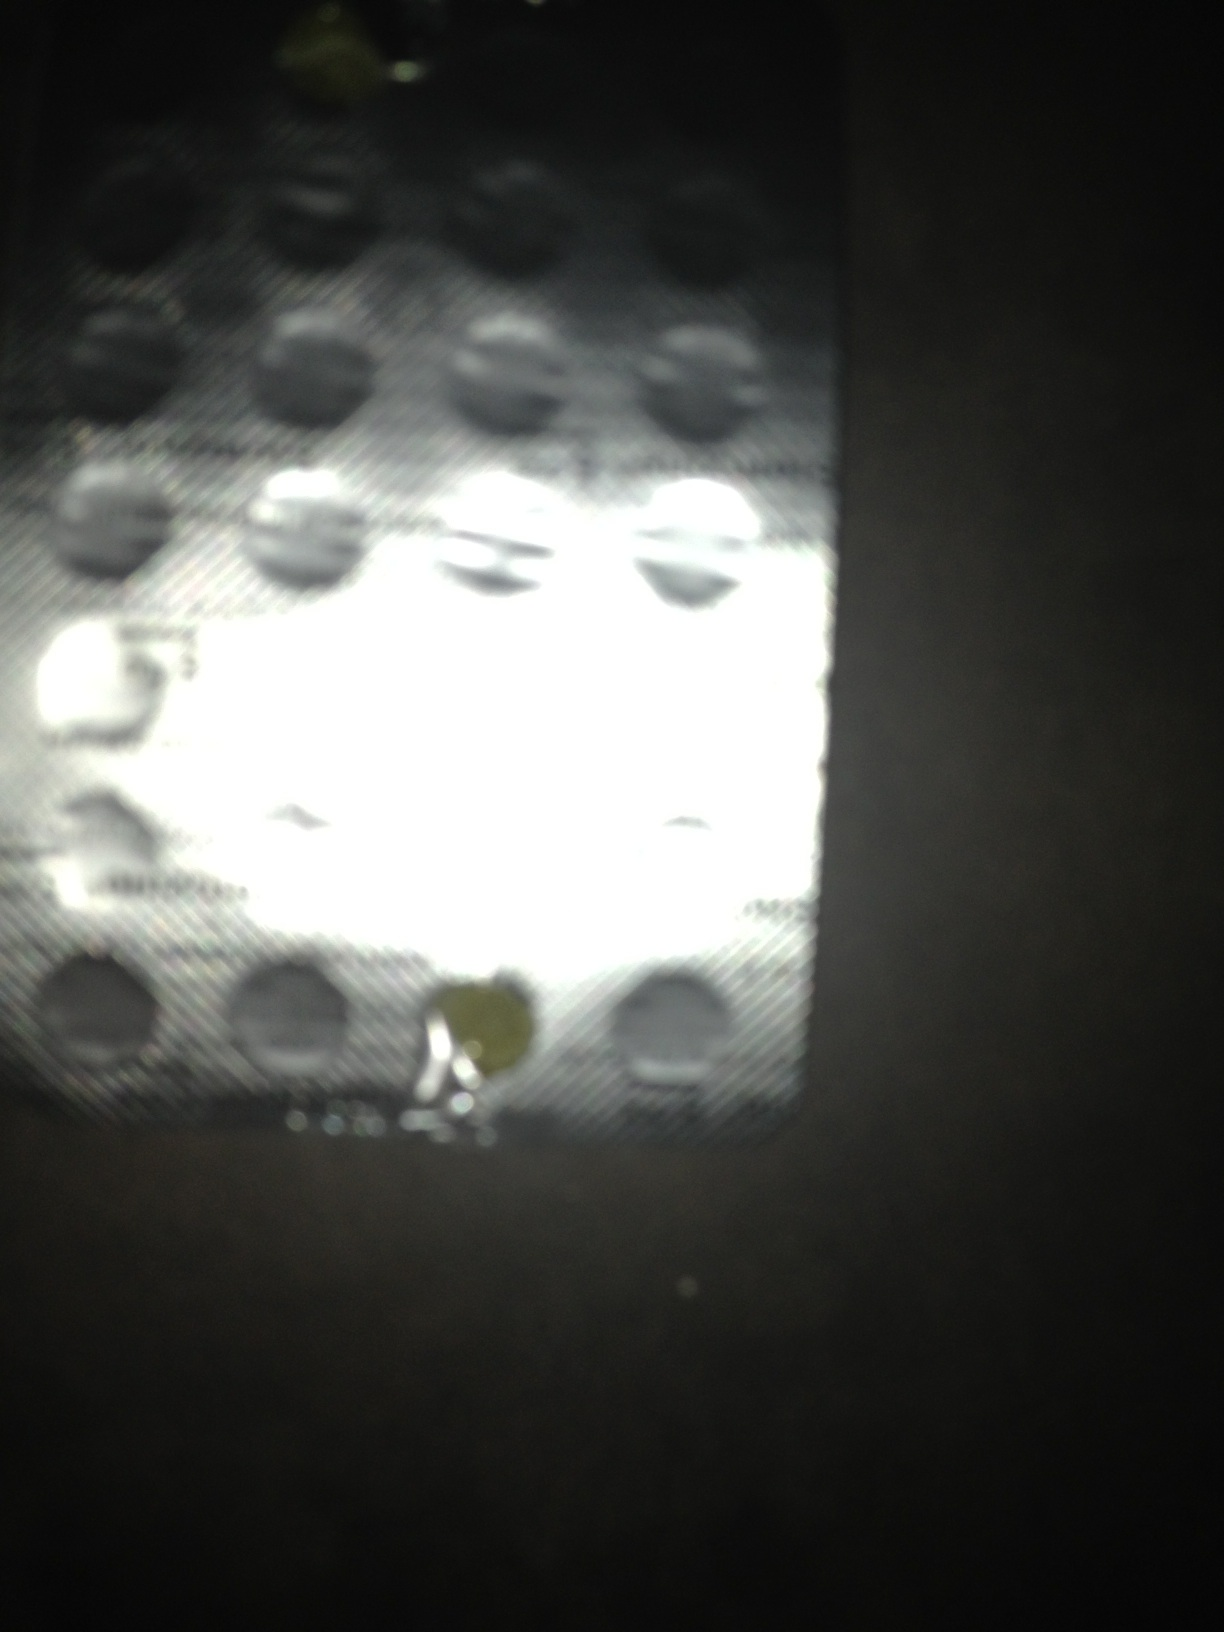How should I store medications like the ones shown to ensure they remain effective? Medications should be stored in a cool, dry place away from direct sunlight and moisture. Make sure the storage area is out of reach of children and pets, and keep the medications in their original packaging until use. 